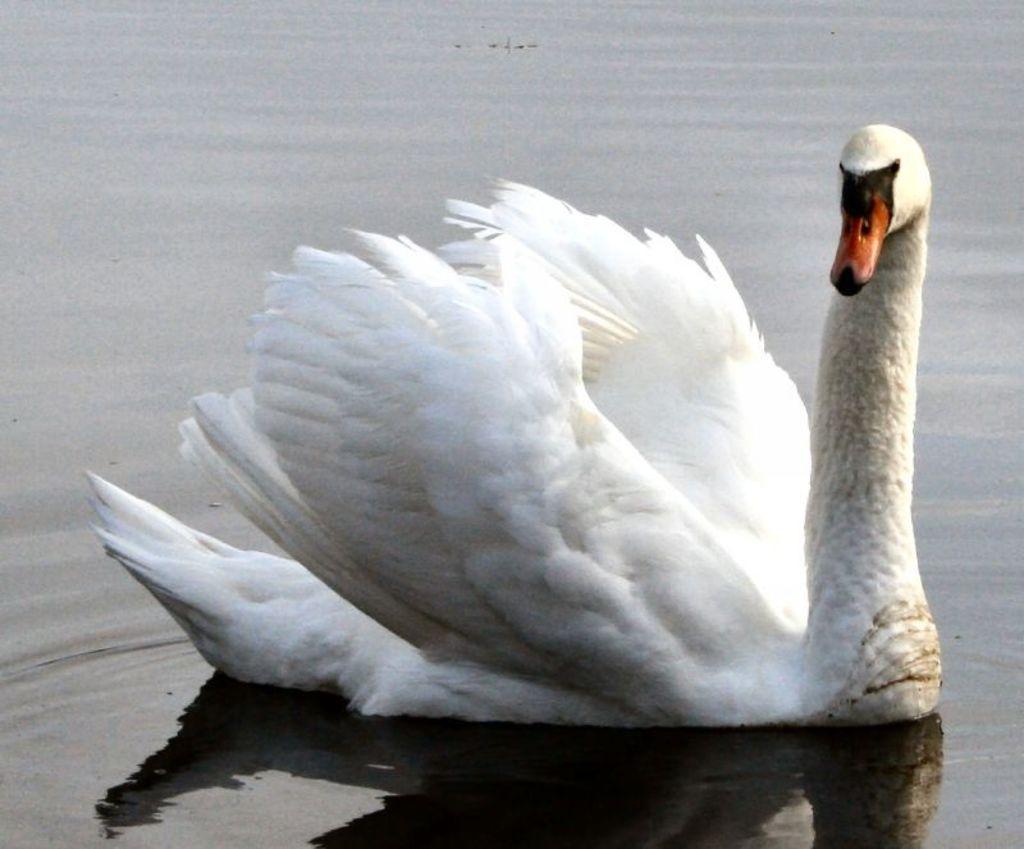Can you describe this image briefly? This image is taken outdoors. At the bottom of the image there is a pond with water. In the middle of the image there is a swan in the pond and it is white in color. 